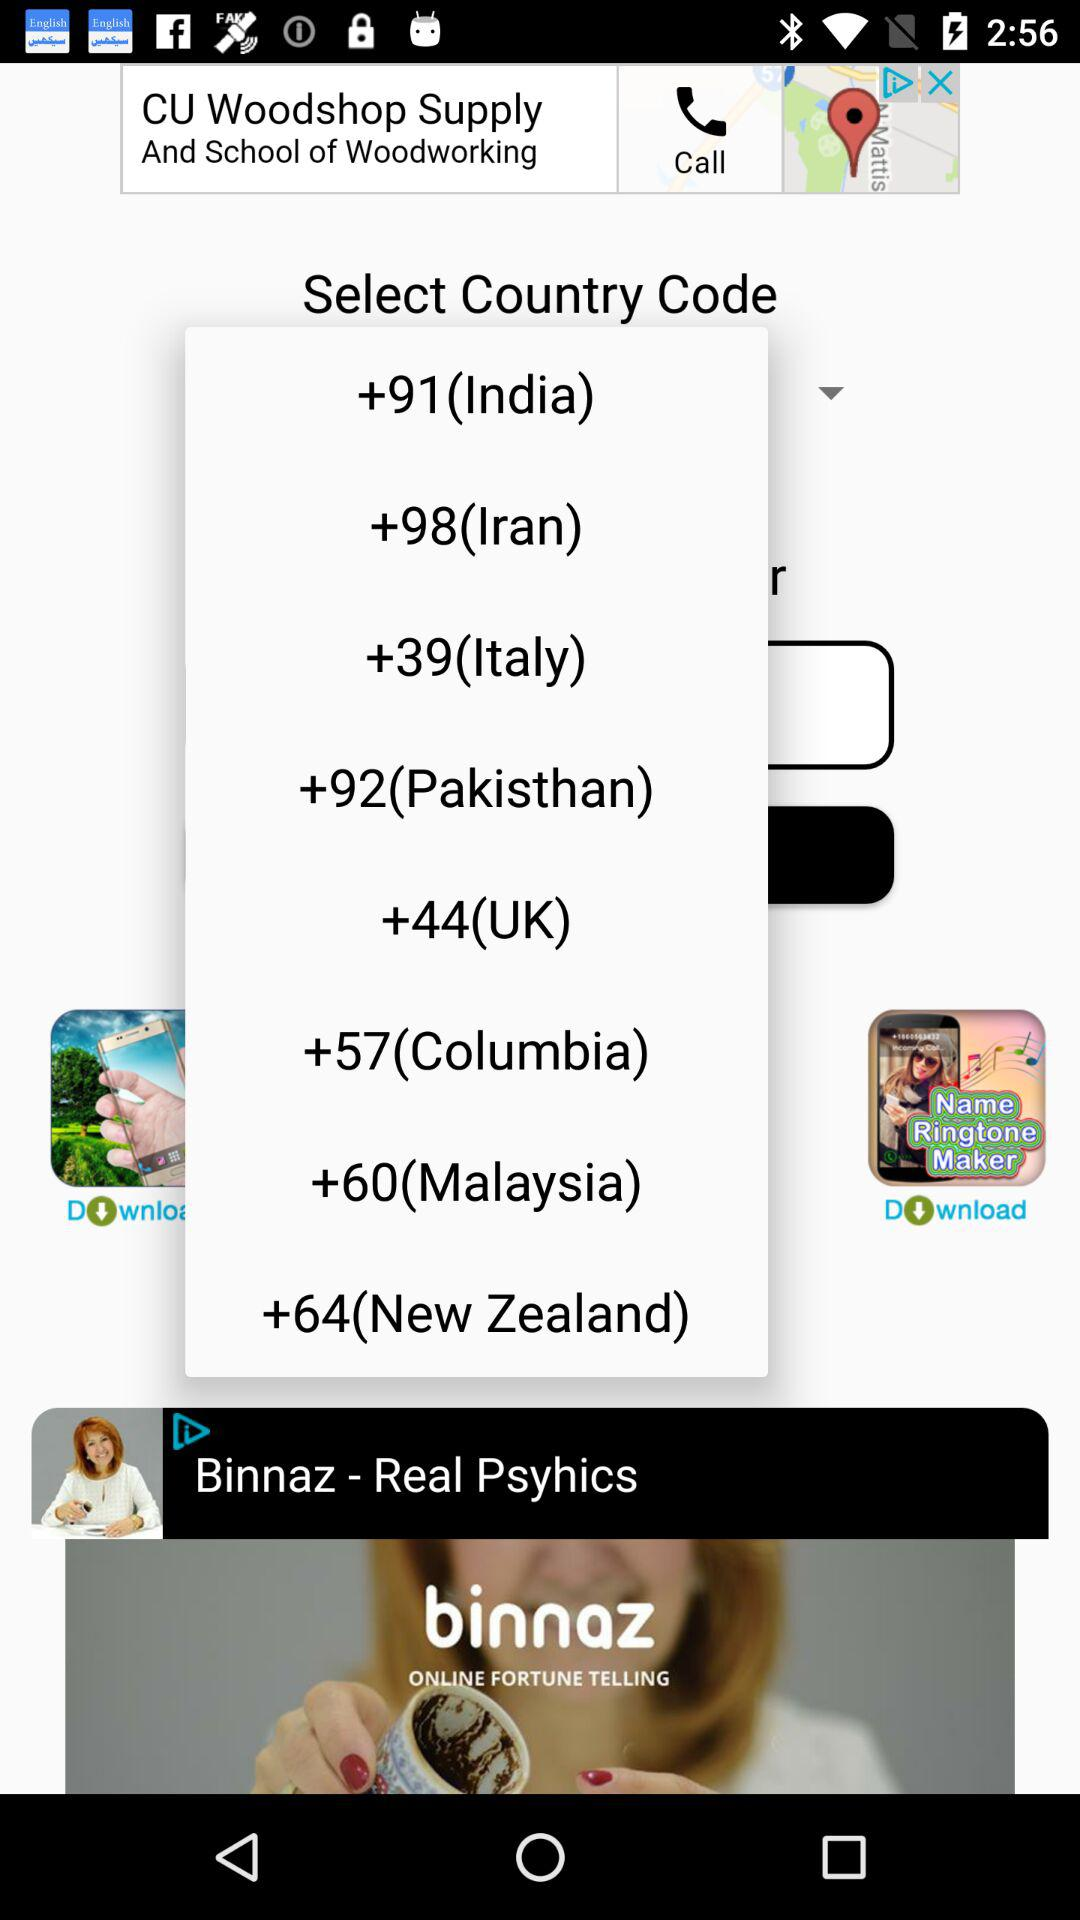What is the country code for Iran? The country code for Iran is +98. 